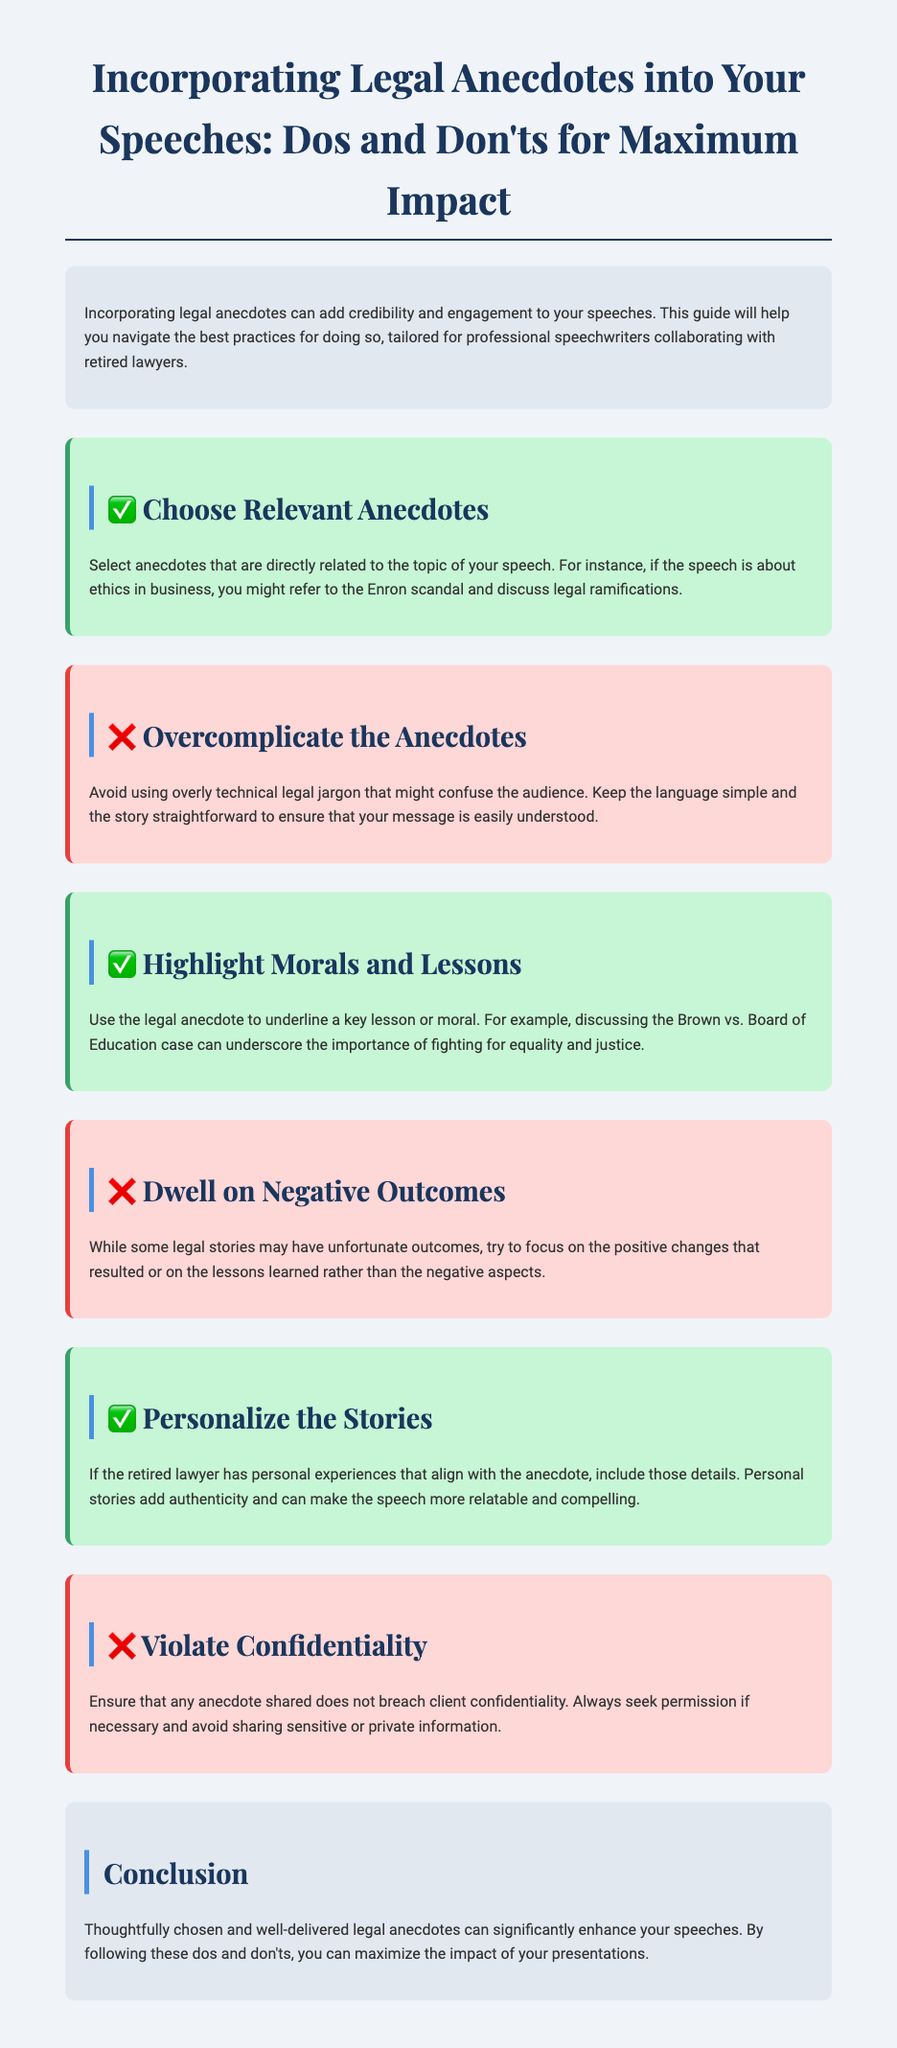What is the title of the document? The title is indicated at the top of the document and summarizes its purpose.
Answer: Incorporating Legal Anecdotes into Your Speeches: Dos and Don'ts for Maximum Impact How many 'Do' sections are included in the guide? The document features multiple sections categorized as 'Do' items for best practices.
Answer: 4 What example is given to highlight a legal moral lesson? The document provides a specific case that illustrates the importance of fighting for equality and justice.
Answer: Brown vs. Board of Education What is emphasized to avoid in the anecdotes? The guide specifies certain aspects to refrain from in storytelling during speeches.
Answer: Overcomplicate the Anecdotes What color is used for the 'Do' sections? The visual presentation of the document includes color coding for different sections.
Answer: Light green 